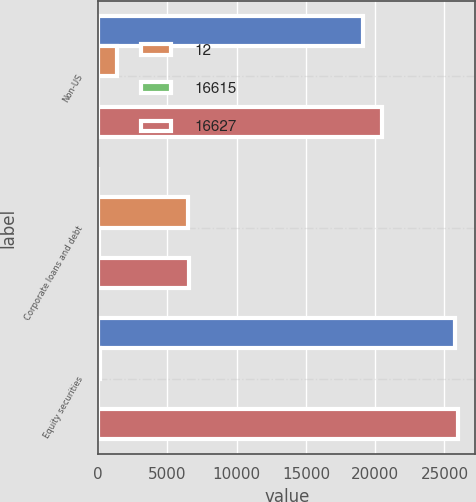Convert chart to OTSL. <chart><loc_0><loc_0><loc_500><loc_500><stacked_bar_chart><ecel><fcel>Non-US<fcel>Corporate loans and debt<fcel>Equity securities<nl><fcel>nan<fcel>19137<fcel>2<fcel>25768<nl><fcel>12<fcel>1364<fcel>6524<fcel>156<nl><fcel>16615<fcel>1<fcel>44<fcel>17<nl><fcel>16627<fcel>20502<fcel>6570<fcel>25941<nl></chart> 